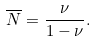<formula> <loc_0><loc_0><loc_500><loc_500>\overline { N } = \frac { \nu } { 1 - \nu } .</formula> 